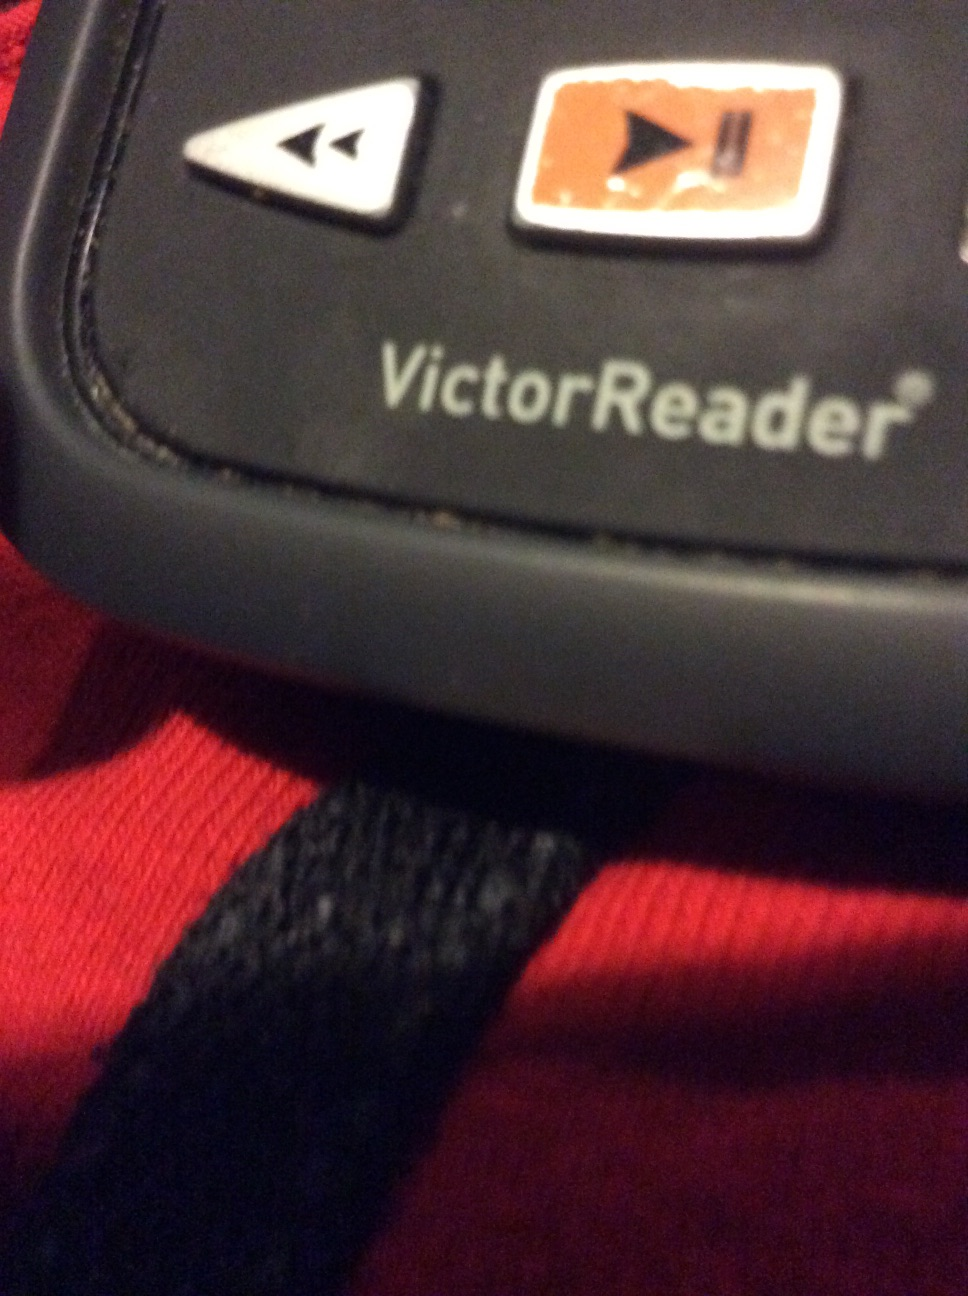What is this? This is a VictorReader, a device designed to assist visually impaired individuals in reading and navigating written content. It features buttons for navigation and playback control, allowing users to read books, documents, and other texts via audio output. 